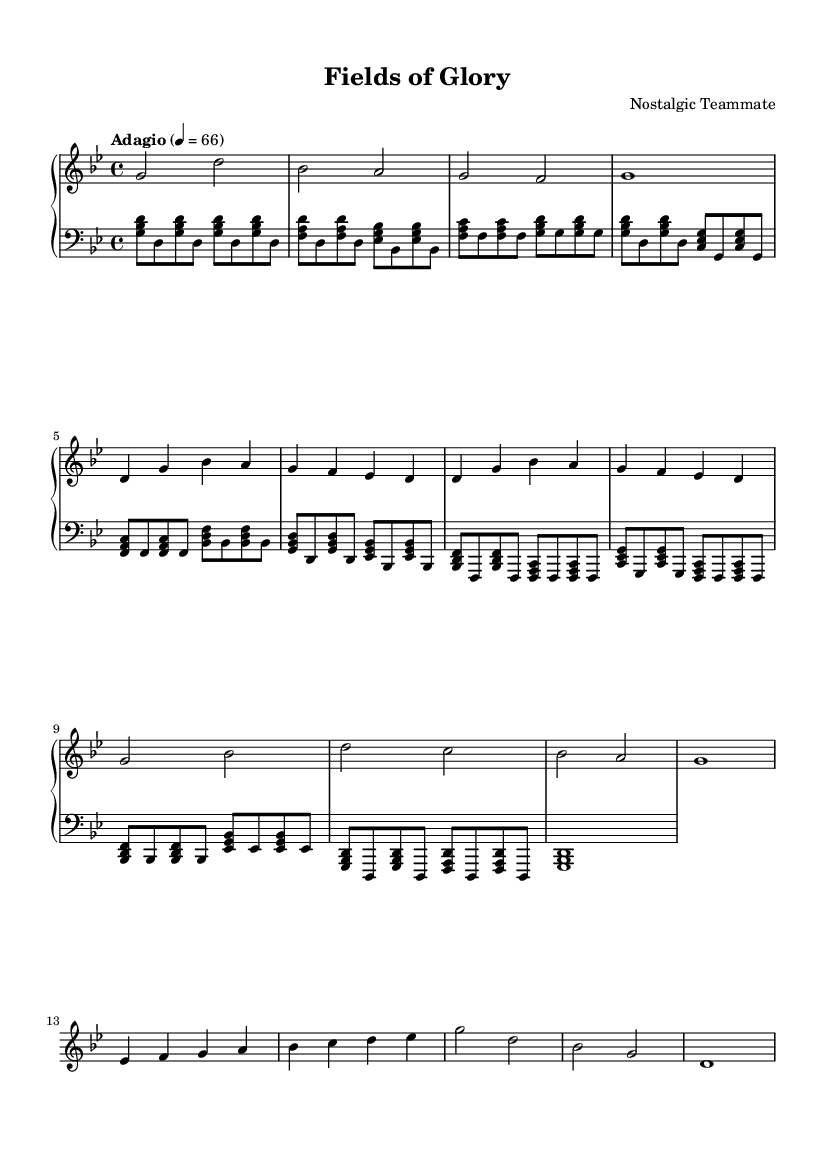What is the key signature of this music? The key signature is one flat, indicating that the piece is in G minor, as there is a flat designation in the key signature area on the staff.
Answer: G minor What is the time signature of this music? The time signature is found in the beginning of the sheet music, represented by "4/4", which indicates that there are four beats in each measure.
Answer: 4/4 What is the tempo marking indicated for this piece? The tempo marking is located above the music and is marked as "Adagio", which indicates a slow pace. The number "66" tells us there are 66 beats per minute.
Answer: Adagio How many measures are in the chorus section of the music? To find the number of measures, we can count the sections marked as the chorus; there are four measures indicated in the chorus section of the sheet music.
Answer: 4 What is the first chord played in the intro? The first chord is shown at the beginning of the sheet music; it is a G major chord, represented in the left-hand part with the notes G, B flat, and D.
Answer: G major What is unique about the structure of this piece compared to traditional songs? This piece includes segments like ‘Intro’, ‘Verse’, ‘Chorus’, and ‘Bridge’; this structured layout creates a cinematic feel typical of soundtracks.
Answer: Structured sections What emotion does this piano composition aim to evoke through its melody? The composition is designed to evoke nostalgia through its slow, emotional melodies that reflect past victories and defeats, which is a characteristic of emotional soundtracks.
Answer: Nostalgia 